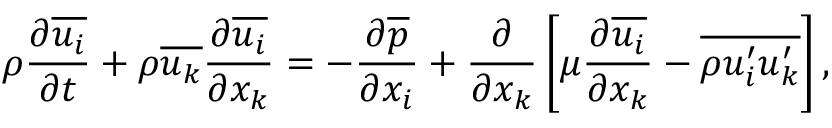Convert formula to latex. <formula><loc_0><loc_0><loc_500><loc_500>\rho \frac { \partial { \overline { { u _ { i } } } } } { \partial { t } } + \rho \overline { { u _ { k } } } \frac { \partial { \overline { { u _ { i } } } } } { \partial { x _ { k } } } = - \frac { \partial { \overline { p } } } { \partial { x _ { i } } } + \frac { \partial } { \partial { x } _ { k } } \left [ \mu \frac { \partial { \overline { { u _ { i } } } } } { \partial { x } _ { k } } - \overline { { \rho { u _ { i } ^ { \prime } } { u _ { k } ^ { \prime } } } } \right ] ,</formula> 